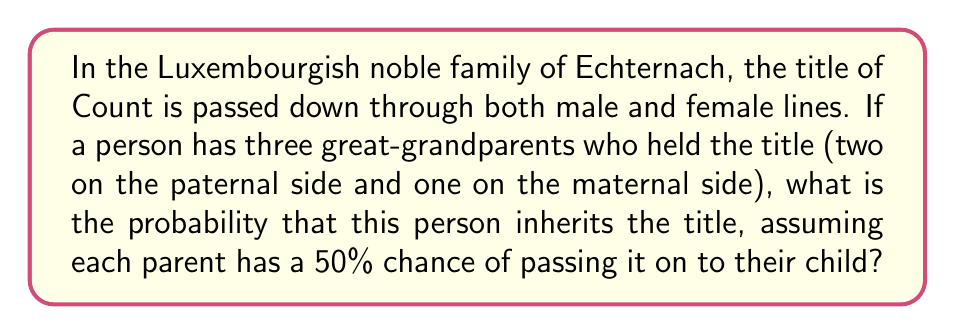Help me with this question. Let's approach this step-by-step:

1) First, we need to calculate the probability of inheriting the title from each great-grandparent:

   - For each great-grandparent, the title must be passed through two generations to reach our person.
   - The probability of passing through each generation is 50% or 0.5.
   - So, for each great-grandparent, the probability is: $0.5 \times 0.5 = 0.25$ or $\frac{1}{4}$

2) Now, we have three independent paths through which the person could inherit the title:
   - Two from the paternal side (P1 and P2)
   - One from the maternal side (M)

3) The probability of NOT inheriting the title from a specific great-grandparent is $1 - \frac{1}{4} = \frac{3}{4}$

4) For our person to NOT inherit the title at all, they must not inherit it from any of the three paths. The probability of this is:

   $$P(\text{not inheriting}) = \frac{3}{4} \times \frac{3}{4} \times \frac{3}{4} = \left(\frac{3}{4}\right)^3 = \frac{27}{64}$$

5) Therefore, the probability of inheriting the title is the opposite of not inheriting:

   $$P(\text{inheriting}) = 1 - P(\text{not inheriting}) = 1 - \frac{27}{64} = \frac{64-27}{64} = \frac{37}{64}$$

6) This can be simplified to:

   $$P(\text{inheriting}) = \frac{37}{64} \approx 0.578125 \text{ or about } 57.8\%$$
Answer: $\frac{37}{64}$ 